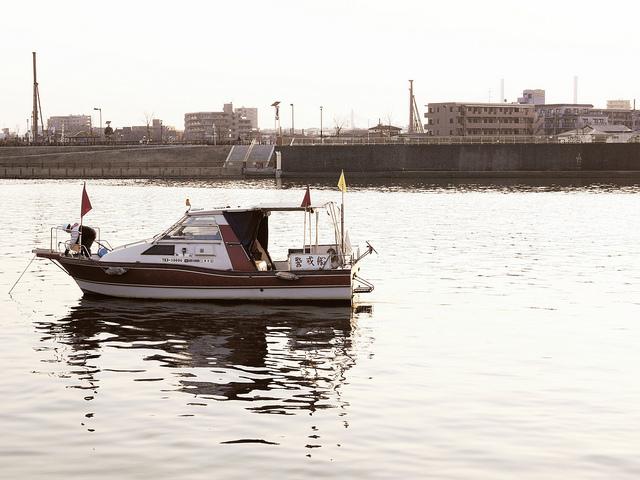What is reflected in the water next to the boat?
Write a very short answer. Boat. Is this a rescue boat?
Concise answer only. No. Is it raining?
Give a very brief answer. No. How many different kinds of flags are posted on the boat?
Answer briefly. 3. 